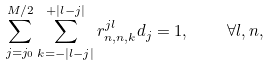Convert formula to latex. <formula><loc_0><loc_0><loc_500><loc_500>\sum _ { j = j _ { 0 } } ^ { M / 2 } \sum _ { k = - | l - j | } ^ { + | l - j | } r _ { n , n , k } ^ { j l } d _ { j } = 1 , \quad \forall l , n ,</formula> 